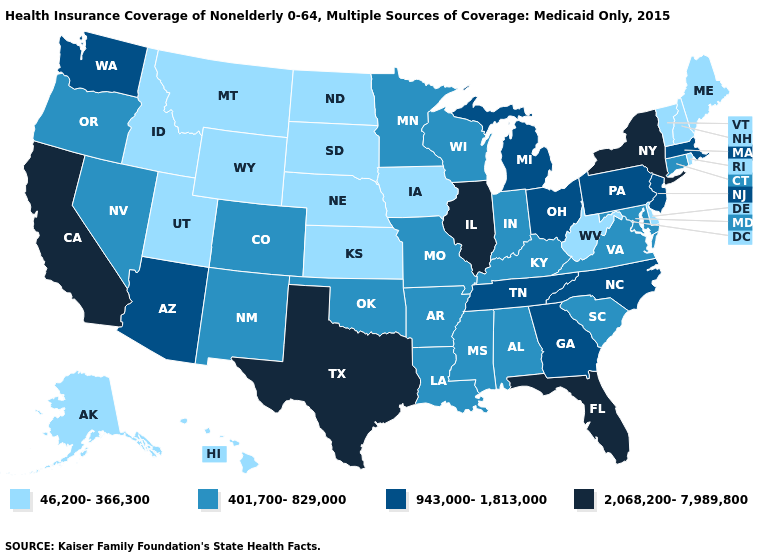Which states have the highest value in the USA?
Give a very brief answer. California, Florida, Illinois, New York, Texas. What is the value of Idaho?
Quick response, please. 46,200-366,300. Name the states that have a value in the range 401,700-829,000?
Be succinct. Alabama, Arkansas, Colorado, Connecticut, Indiana, Kentucky, Louisiana, Maryland, Minnesota, Mississippi, Missouri, Nevada, New Mexico, Oklahoma, Oregon, South Carolina, Virginia, Wisconsin. Which states hav the highest value in the MidWest?
Answer briefly. Illinois. Which states have the lowest value in the USA?
Short answer required. Alaska, Delaware, Hawaii, Idaho, Iowa, Kansas, Maine, Montana, Nebraska, New Hampshire, North Dakota, Rhode Island, South Dakota, Utah, Vermont, West Virginia, Wyoming. What is the lowest value in states that border Alabama?
Be succinct. 401,700-829,000. Among the states that border Michigan , which have the lowest value?
Keep it brief. Indiana, Wisconsin. What is the value of North Carolina?
Write a very short answer. 943,000-1,813,000. Name the states that have a value in the range 2,068,200-7,989,800?
Answer briefly. California, Florida, Illinois, New York, Texas. Does Ohio have the same value as California?
Write a very short answer. No. Among the states that border Michigan , which have the highest value?
Write a very short answer. Ohio. Which states have the highest value in the USA?
Write a very short answer. California, Florida, Illinois, New York, Texas. What is the lowest value in the USA?
Write a very short answer. 46,200-366,300. Name the states that have a value in the range 2,068,200-7,989,800?
Short answer required. California, Florida, Illinois, New York, Texas. Does the map have missing data?
Keep it brief. No. 